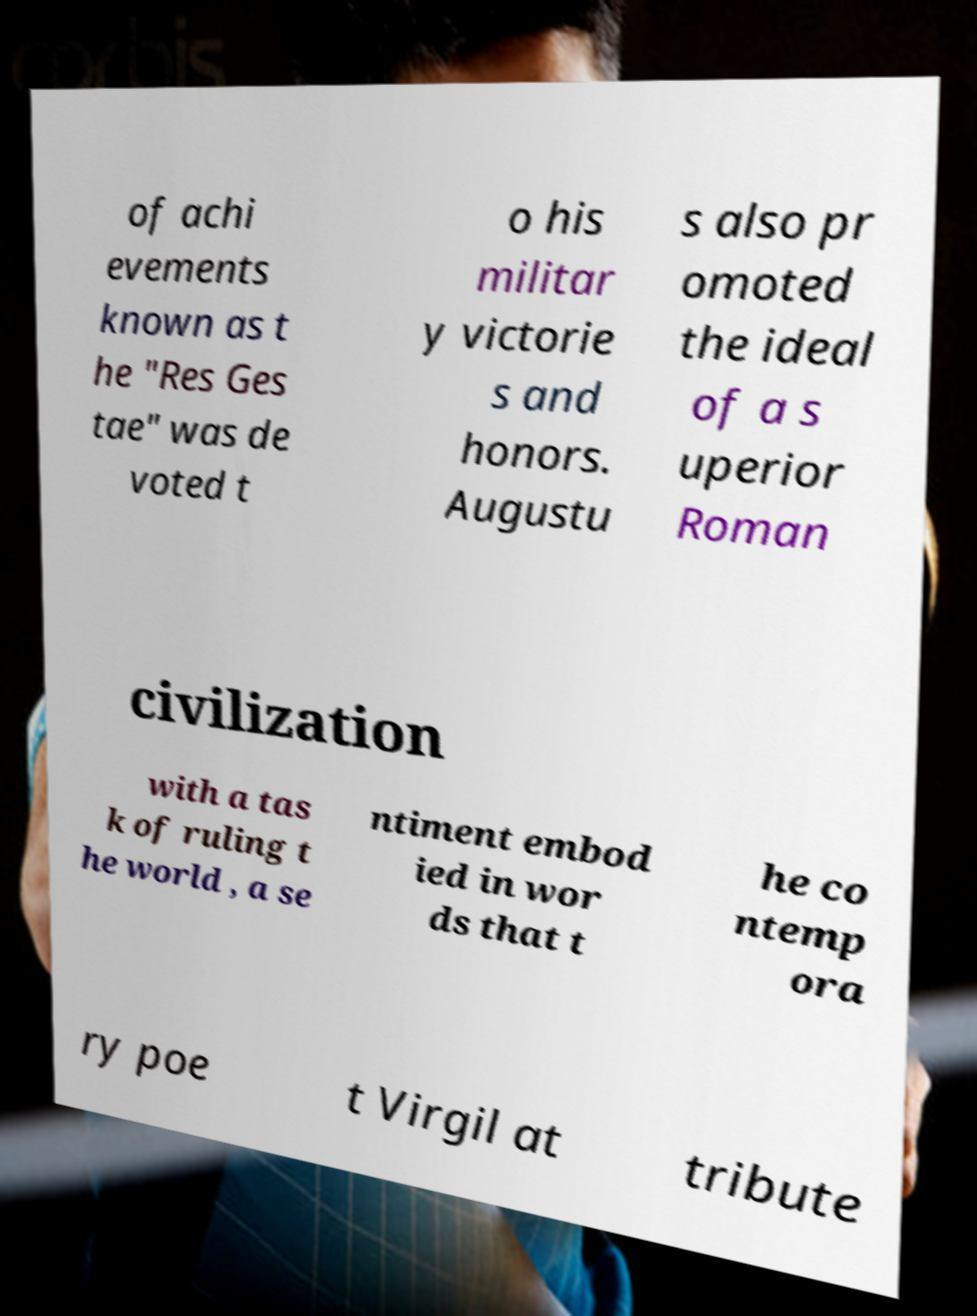There's text embedded in this image that I need extracted. Can you transcribe it verbatim? of achi evements known as t he "Res Ges tae" was de voted t o his militar y victorie s and honors. Augustu s also pr omoted the ideal of a s uperior Roman civilization with a tas k of ruling t he world , a se ntiment embod ied in wor ds that t he co ntemp ora ry poe t Virgil at tribute 